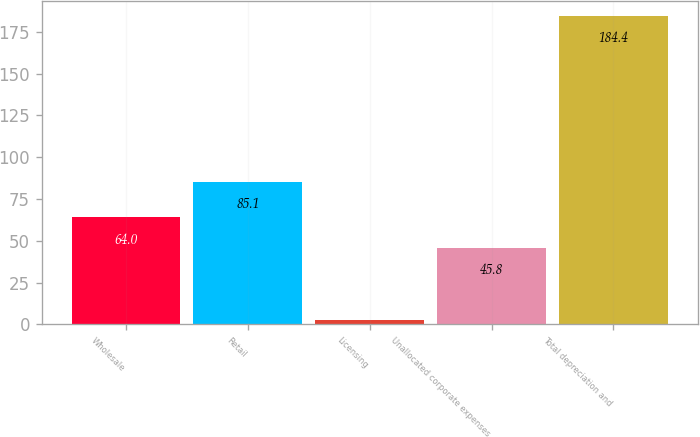Convert chart to OTSL. <chart><loc_0><loc_0><loc_500><loc_500><bar_chart><fcel>Wholesale<fcel>Retail<fcel>Licensing<fcel>Unallocated corporate expenses<fcel>Total depreciation and<nl><fcel>64<fcel>85.1<fcel>2.4<fcel>45.8<fcel>184.4<nl></chart> 